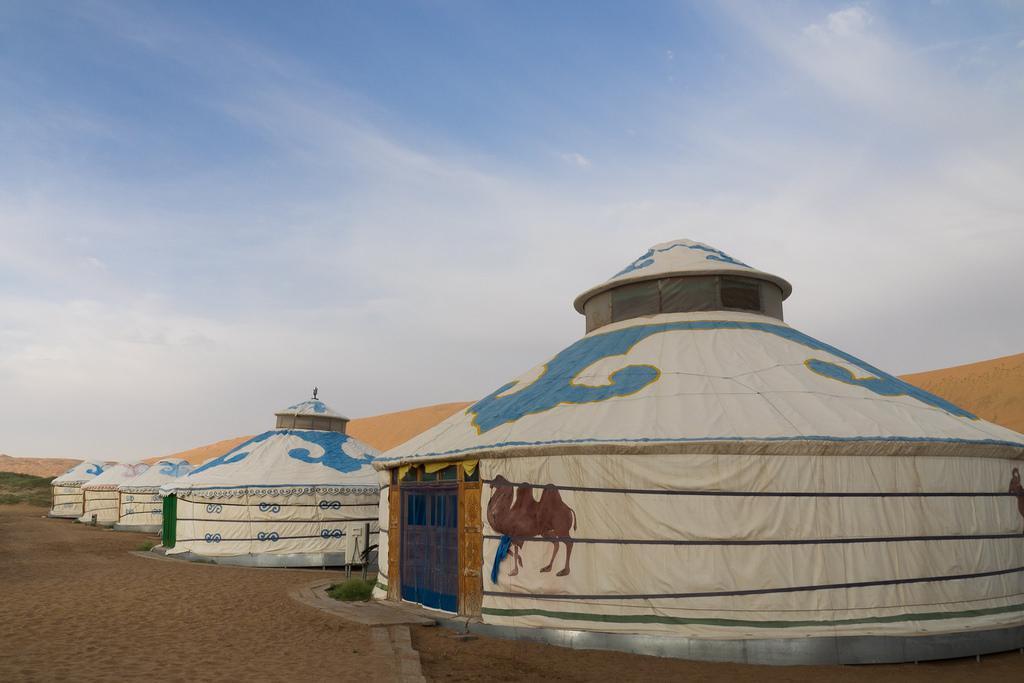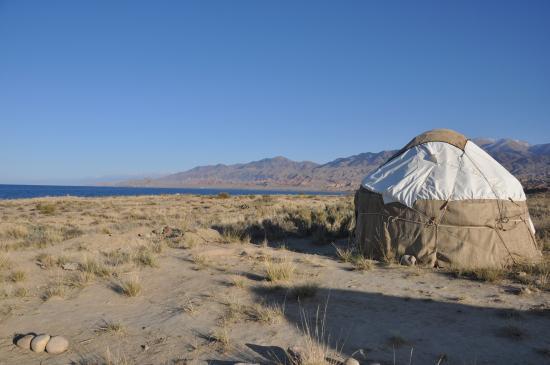The first image is the image on the left, the second image is the image on the right. Given the left and right images, does the statement "At least seven yurts of the same style are shown in a scrubby dessert setting in one image, while a second image shows at least 2 yurts." hold true? Answer yes or no. No. The first image is the image on the left, the second image is the image on the right. Given the left and right images, does the statement "An image shows a group of round structures covered in brown material crossed with straps." hold true? Answer yes or no. No. 